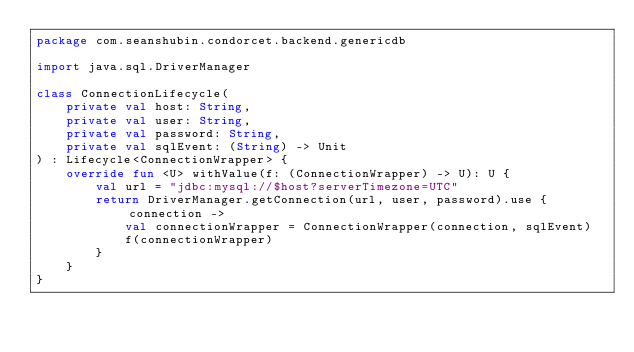Convert code to text. <code><loc_0><loc_0><loc_500><loc_500><_Kotlin_>package com.seanshubin.condorcet.backend.genericdb

import java.sql.DriverManager

class ConnectionLifecycle(
    private val host: String,
    private val user: String,
    private val password: String,
    private val sqlEvent: (String) -> Unit
) : Lifecycle<ConnectionWrapper> {
    override fun <U> withValue(f: (ConnectionWrapper) -> U): U {
        val url = "jdbc:mysql://$host?serverTimezone=UTC"
        return DriverManager.getConnection(url, user, password).use { connection ->
            val connectionWrapper = ConnectionWrapper(connection, sqlEvent)
            f(connectionWrapper)
        }
    }
}
</code> 